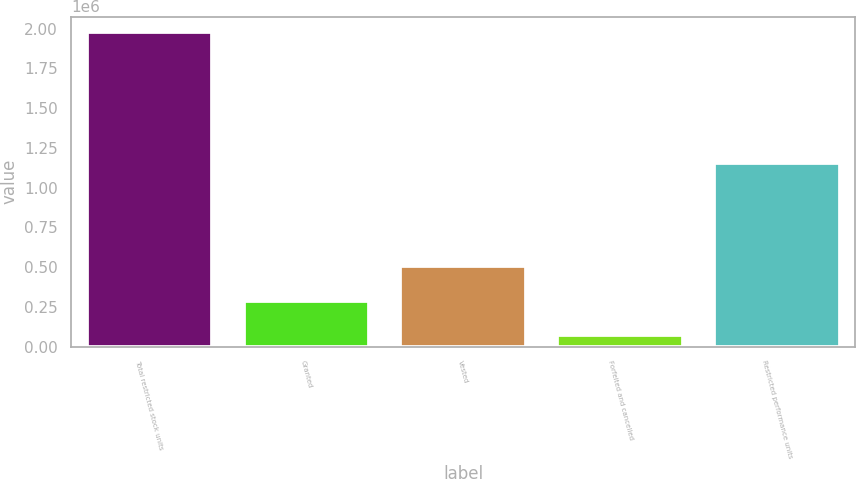Convert chart. <chart><loc_0><loc_0><loc_500><loc_500><bar_chart><fcel>Total restricted stock units<fcel>Granted<fcel>Vested<fcel>Forfeited and cancelled<fcel>Restricted performance units<nl><fcel>1.97594e+06<fcel>289428<fcel>506190<fcel>72666<fcel>1.15594e+06<nl></chart> 